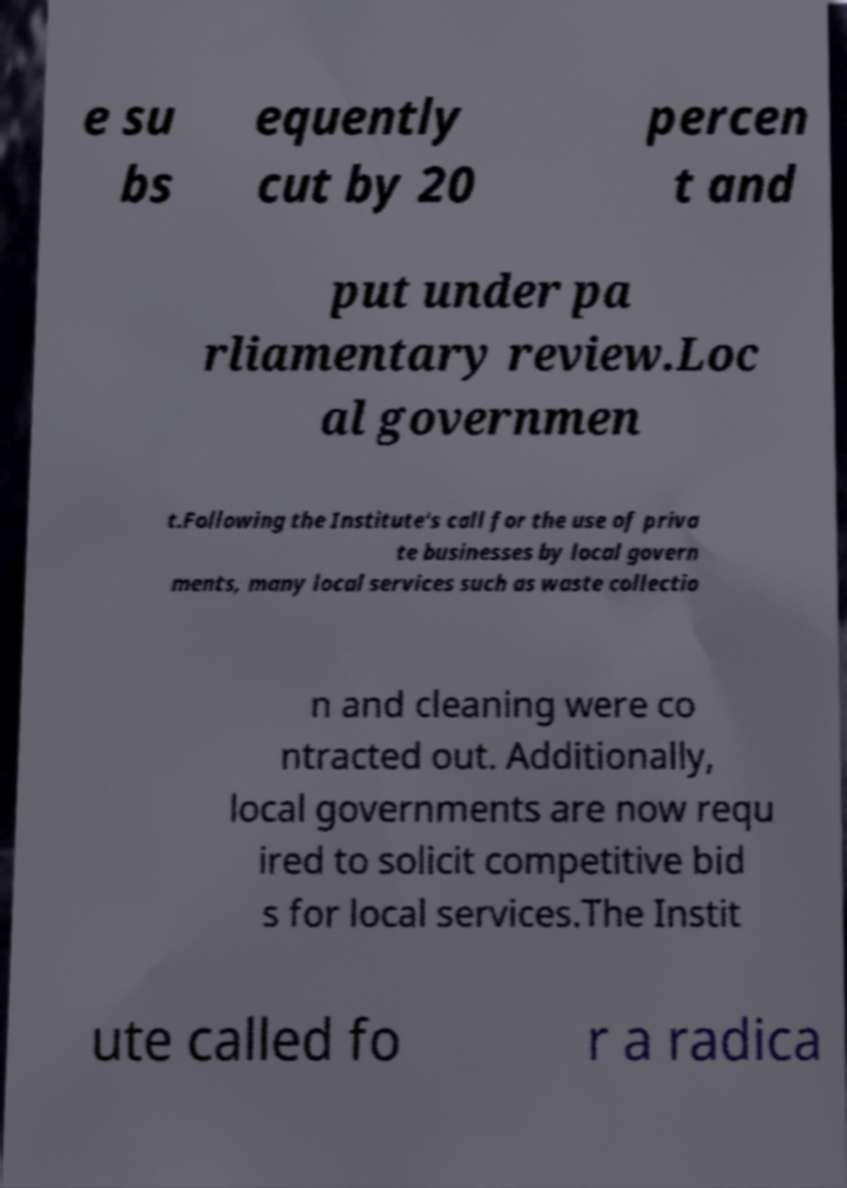Please identify and transcribe the text found in this image. e su bs equently cut by 20 percen t and put under pa rliamentary review.Loc al governmen t.Following the Institute's call for the use of priva te businesses by local govern ments, many local services such as waste collectio n and cleaning were co ntracted out. Additionally, local governments are now requ ired to solicit competitive bid s for local services.The Instit ute called fo r a radica 